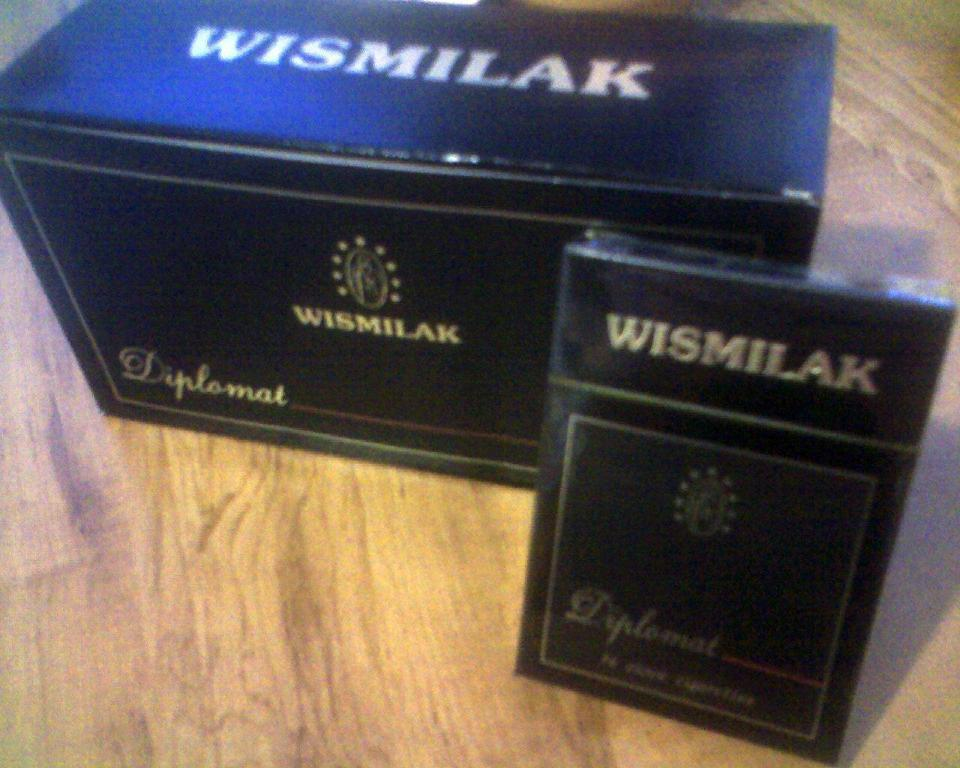<image>
Describe the image concisely. Two boxes that say Wismilak diplomat are on the a wooden floor. 